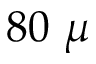<formula> <loc_0><loc_0><loc_500><loc_500>8 0 \mu</formula> 